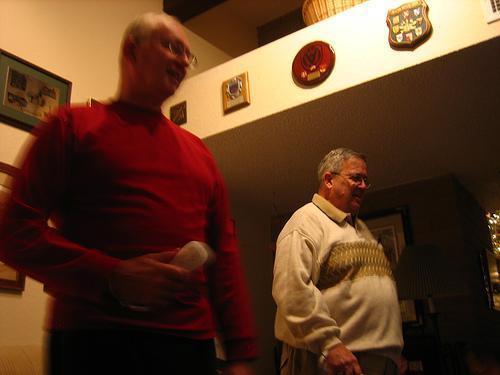How many men are there?
Give a very brief answer. 2. 